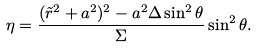<formula> <loc_0><loc_0><loc_500><loc_500>\eta = \frac { ( \tilde { r } ^ { 2 } + a ^ { 2 } ) ^ { 2 } - a ^ { 2 } \Delta \sin ^ { 2 } \theta } { \Sigma } \sin ^ { 2 } \theta .</formula> 